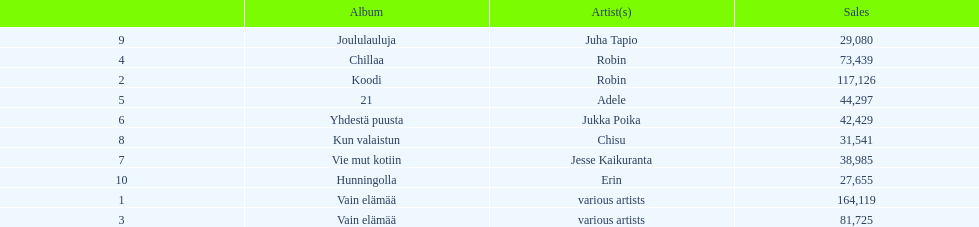Which was the last album to sell over 100,000 records? Koodi. 